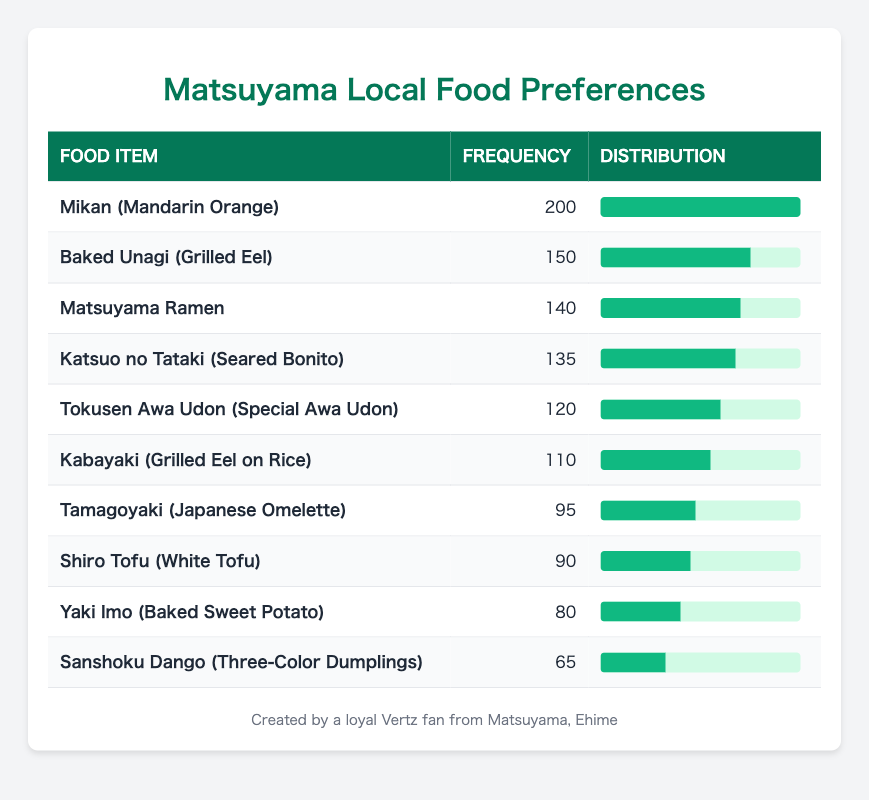What is the food item with the highest frequency preference among Matsuyama residents? From the table, we can see that "Mikan (Mandarin Orange)" has the frequency of 200, which is the highest compared to all other food items listed.
Answer: Mikan (Mandarin Orange) How many residents prefer 'Katsuo no Tataki (Seared Bonito)'? The frequency for 'Katsuo no Tataki (Seared Bonito)' is directly shown in the table as 135.
Answer: 135 Is the frequency of 'Shiro Tofu (White Tofu)' greater than 100? Looking at the frequency listed in the table, 'Shiro Tofu (White Tofu)' has a frequency of 90, which is not greater than 100.
Answer: No What is the total frequency of all the food items listed? To find the total frequency, we add all the individual frequencies: 200 + 150 + 140 + 135 + 120 + 110 + 95 + 90 + 80 + 65 = 1,100. Thus, the total frequency is 1,100.
Answer: 1,100 Which food item has a frequency closest to 100? Looking at the table, 'Kabayaki (Grilled Eel on Rice)' has a frequency of 110, and 'Shiro Tofu (White Tofu)' has a frequency of 90, making 'Kabayaki (Grilled Eel on Rice)' the closest to 100.
Answer: Kabayaki (Grilled Eel on Rice) What is the average frequency of the food preferences given in the table? To calculate the average, we divide the total frequency (1,100) by the number of food items (10): 1,100 / 10 = 110. So the average frequency is 110.
Answer: 110 How many food items have a frequency greater than 100? In the table, we find the frequencies greater than 100: 'Mikan (Mandarin Orange)', 'Baked Unagi (Grilled Eel)', 'Matsuyama Ramen', 'Katsuo no Tataki (Seared Bonito)', and 'Tokusen Awa Udon (Special Awa Udon)', totaling to 5 food items.
Answer: 5 What is the difference in frequency between 'Mikan (Mandarin Orange)' and 'Yaki Imo (Baked Sweet Potato)'? The frequency of 'Mikan (Mandarin Orange)' is 200 and 'Yaki Imo (Baked Sweet Potato)' has a frequency of 80. The difference is 200 - 80 = 120.
Answer: 120 Which food item has the lowest frequency among Matsuyama residents? From the table, 'Sanshoku Dango (Three-Color Dumplings)' has the lowest frequency listed, which is 65.
Answer: Sanshoku Dango (Three-Color Dumplings) 